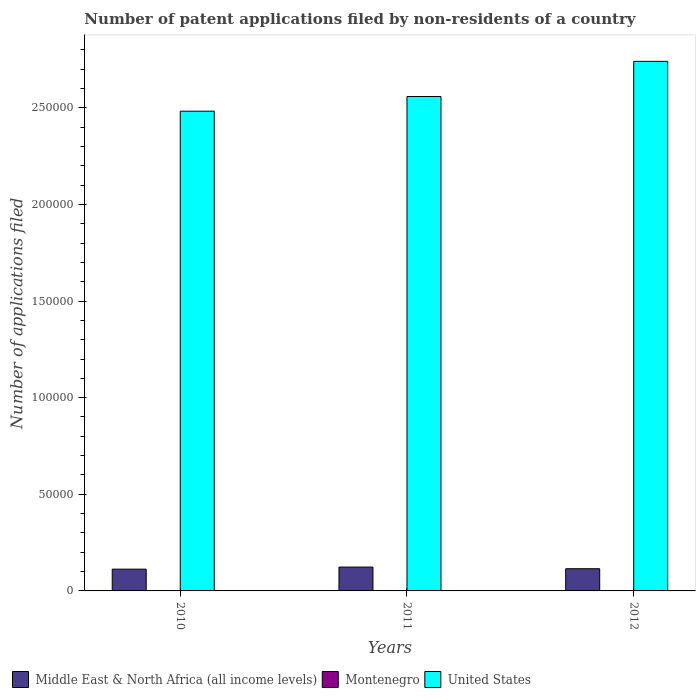How many groups of bars are there?
Provide a succinct answer. 3. Are the number of bars on each tick of the X-axis equal?
Your answer should be compact. Yes. How many bars are there on the 3rd tick from the left?
Keep it short and to the point. 3. What is the label of the 3rd group of bars from the left?
Ensure brevity in your answer.  2012. Across all years, what is the maximum number of applications filed in Middle East & North Africa (all income levels)?
Offer a very short reply. 1.23e+04. Across all years, what is the minimum number of applications filed in Middle East & North Africa (all income levels)?
Give a very brief answer. 1.13e+04. In which year was the number of applications filed in Montenegro maximum?
Give a very brief answer. 2010. In which year was the number of applications filed in Montenegro minimum?
Make the answer very short. 2012. What is the total number of applications filed in Middle East & North Africa (all income levels) in the graph?
Keep it short and to the point. 3.51e+04. What is the difference between the number of applications filed in United States in 2010 and that in 2011?
Keep it short and to the point. -7583. What is the difference between the number of applications filed in Middle East & North Africa (all income levels) in 2011 and the number of applications filed in Montenegro in 2012?
Make the answer very short. 1.23e+04. What is the average number of applications filed in Montenegro per year?
Offer a terse response. 86.67. In the year 2012, what is the difference between the number of applications filed in Montenegro and number of applications filed in United States?
Your response must be concise. -2.74e+05. In how many years, is the number of applications filed in Montenegro greater than 80000?
Provide a succinct answer. 0. What is the ratio of the number of applications filed in Montenegro in 2010 to that in 2011?
Ensure brevity in your answer.  1.64. Is the number of applications filed in Middle East & North Africa (all income levels) in 2010 less than that in 2011?
Your answer should be compact. Yes. Is the difference between the number of applications filed in Montenegro in 2011 and 2012 greater than the difference between the number of applications filed in United States in 2011 and 2012?
Keep it short and to the point. Yes. What is the difference between the highest and the second highest number of applications filed in Middle East & North Africa (all income levels)?
Offer a very short reply. 858. What is the difference between the highest and the lowest number of applications filed in Middle East & North Africa (all income levels)?
Offer a very short reply. 1079. In how many years, is the number of applications filed in United States greater than the average number of applications filed in United States taken over all years?
Give a very brief answer. 1. What does the 2nd bar from the right in 2012 represents?
Your answer should be compact. Montenegro. Is it the case that in every year, the sum of the number of applications filed in Middle East & North Africa (all income levels) and number of applications filed in Montenegro is greater than the number of applications filed in United States?
Keep it short and to the point. No. How many bars are there?
Your answer should be very brief. 9. What is the difference between two consecutive major ticks on the Y-axis?
Ensure brevity in your answer.  5.00e+04. Are the values on the major ticks of Y-axis written in scientific E-notation?
Your answer should be very brief. No. Does the graph contain grids?
Offer a very short reply. No. Where does the legend appear in the graph?
Your response must be concise. Bottom left. How many legend labels are there?
Your answer should be very brief. 3. What is the title of the graph?
Keep it short and to the point. Number of patent applications filed by non-residents of a country. What is the label or title of the Y-axis?
Ensure brevity in your answer.  Number of applications filed. What is the Number of applications filed in Middle East & North Africa (all income levels) in 2010?
Keep it short and to the point. 1.13e+04. What is the Number of applications filed of Montenegro in 2010?
Ensure brevity in your answer.  136. What is the Number of applications filed of United States in 2010?
Make the answer very short. 2.48e+05. What is the Number of applications filed of Middle East & North Africa (all income levels) in 2011?
Your answer should be very brief. 1.23e+04. What is the Number of applications filed of United States in 2011?
Your response must be concise. 2.56e+05. What is the Number of applications filed of Middle East & North Africa (all income levels) in 2012?
Make the answer very short. 1.15e+04. What is the Number of applications filed in Montenegro in 2012?
Provide a short and direct response. 41. What is the Number of applications filed in United States in 2012?
Your answer should be very brief. 2.74e+05. Across all years, what is the maximum Number of applications filed of Middle East & North Africa (all income levels)?
Your response must be concise. 1.23e+04. Across all years, what is the maximum Number of applications filed of Montenegro?
Make the answer very short. 136. Across all years, what is the maximum Number of applications filed in United States?
Your answer should be compact. 2.74e+05. Across all years, what is the minimum Number of applications filed of Middle East & North Africa (all income levels)?
Provide a succinct answer. 1.13e+04. Across all years, what is the minimum Number of applications filed in Montenegro?
Your answer should be compact. 41. Across all years, what is the minimum Number of applications filed in United States?
Keep it short and to the point. 2.48e+05. What is the total Number of applications filed in Middle East & North Africa (all income levels) in the graph?
Ensure brevity in your answer.  3.51e+04. What is the total Number of applications filed in Montenegro in the graph?
Your answer should be very brief. 260. What is the total Number of applications filed in United States in the graph?
Make the answer very short. 7.78e+05. What is the difference between the Number of applications filed in Middle East & North Africa (all income levels) in 2010 and that in 2011?
Offer a terse response. -1079. What is the difference between the Number of applications filed in Montenegro in 2010 and that in 2011?
Give a very brief answer. 53. What is the difference between the Number of applications filed in United States in 2010 and that in 2011?
Give a very brief answer. -7583. What is the difference between the Number of applications filed in Middle East & North Africa (all income levels) in 2010 and that in 2012?
Keep it short and to the point. -221. What is the difference between the Number of applications filed of Montenegro in 2010 and that in 2012?
Keep it short and to the point. 95. What is the difference between the Number of applications filed of United States in 2010 and that in 2012?
Your answer should be very brief. -2.58e+04. What is the difference between the Number of applications filed of Middle East & North Africa (all income levels) in 2011 and that in 2012?
Your answer should be very brief. 858. What is the difference between the Number of applications filed in United States in 2011 and that in 2012?
Provide a short and direct response. -1.82e+04. What is the difference between the Number of applications filed in Middle East & North Africa (all income levels) in 2010 and the Number of applications filed in Montenegro in 2011?
Keep it short and to the point. 1.12e+04. What is the difference between the Number of applications filed of Middle East & North Africa (all income levels) in 2010 and the Number of applications filed of United States in 2011?
Make the answer very short. -2.45e+05. What is the difference between the Number of applications filed of Montenegro in 2010 and the Number of applications filed of United States in 2011?
Give a very brief answer. -2.56e+05. What is the difference between the Number of applications filed of Middle East & North Africa (all income levels) in 2010 and the Number of applications filed of Montenegro in 2012?
Provide a short and direct response. 1.12e+04. What is the difference between the Number of applications filed of Middle East & North Africa (all income levels) in 2010 and the Number of applications filed of United States in 2012?
Your answer should be compact. -2.63e+05. What is the difference between the Number of applications filed of Montenegro in 2010 and the Number of applications filed of United States in 2012?
Make the answer very short. -2.74e+05. What is the difference between the Number of applications filed in Middle East & North Africa (all income levels) in 2011 and the Number of applications filed in Montenegro in 2012?
Your answer should be very brief. 1.23e+04. What is the difference between the Number of applications filed of Middle East & North Africa (all income levels) in 2011 and the Number of applications filed of United States in 2012?
Your answer should be very brief. -2.62e+05. What is the difference between the Number of applications filed in Montenegro in 2011 and the Number of applications filed in United States in 2012?
Your answer should be very brief. -2.74e+05. What is the average Number of applications filed of Middle East & North Africa (all income levels) per year?
Provide a succinct answer. 1.17e+04. What is the average Number of applications filed of Montenegro per year?
Offer a very short reply. 86.67. What is the average Number of applications filed in United States per year?
Your answer should be very brief. 2.59e+05. In the year 2010, what is the difference between the Number of applications filed in Middle East & North Africa (all income levels) and Number of applications filed in Montenegro?
Ensure brevity in your answer.  1.11e+04. In the year 2010, what is the difference between the Number of applications filed in Middle East & North Africa (all income levels) and Number of applications filed in United States?
Your answer should be compact. -2.37e+05. In the year 2010, what is the difference between the Number of applications filed of Montenegro and Number of applications filed of United States?
Offer a very short reply. -2.48e+05. In the year 2011, what is the difference between the Number of applications filed of Middle East & North Africa (all income levels) and Number of applications filed of Montenegro?
Offer a terse response. 1.23e+04. In the year 2011, what is the difference between the Number of applications filed of Middle East & North Africa (all income levels) and Number of applications filed of United States?
Provide a short and direct response. -2.43e+05. In the year 2011, what is the difference between the Number of applications filed in Montenegro and Number of applications filed in United States?
Your response must be concise. -2.56e+05. In the year 2012, what is the difference between the Number of applications filed of Middle East & North Africa (all income levels) and Number of applications filed of Montenegro?
Provide a short and direct response. 1.14e+04. In the year 2012, what is the difference between the Number of applications filed in Middle East & North Africa (all income levels) and Number of applications filed in United States?
Offer a very short reply. -2.63e+05. In the year 2012, what is the difference between the Number of applications filed in Montenegro and Number of applications filed in United States?
Give a very brief answer. -2.74e+05. What is the ratio of the Number of applications filed of Middle East & North Africa (all income levels) in 2010 to that in 2011?
Your response must be concise. 0.91. What is the ratio of the Number of applications filed in Montenegro in 2010 to that in 2011?
Offer a very short reply. 1.64. What is the ratio of the Number of applications filed of United States in 2010 to that in 2011?
Provide a succinct answer. 0.97. What is the ratio of the Number of applications filed in Middle East & North Africa (all income levels) in 2010 to that in 2012?
Provide a short and direct response. 0.98. What is the ratio of the Number of applications filed of Montenegro in 2010 to that in 2012?
Ensure brevity in your answer.  3.32. What is the ratio of the Number of applications filed in United States in 2010 to that in 2012?
Offer a terse response. 0.91. What is the ratio of the Number of applications filed in Middle East & North Africa (all income levels) in 2011 to that in 2012?
Ensure brevity in your answer.  1.07. What is the ratio of the Number of applications filed in Montenegro in 2011 to that in 2012?
Make the answer very short. 2.02. What is the ratio of the Number of applications filed of United States in 2011 to that in 2012?
Offer a very short reply. 0.93. What is the difference between the highest and the second highest Number of applications filed in Middle East & North Africa (all income levels)?
Offer a very short reply. 858. What is the difference between the highest and the second highest Number of applications filed in Montenegro?
Offer a terse response. 53. What is the difference between the highest and the second highest Number of applications filed of United States?
Offer a terse response. 1.82e+04. What is the difference between the highest and the lowest Number of applications filed in Middle East & North Africa (all income levels)?
Offer a very short reply. 1079. What is the difference between the highest and the lowest Number of applications filed in United States?
Your response must be concise. 2.58e+04. 